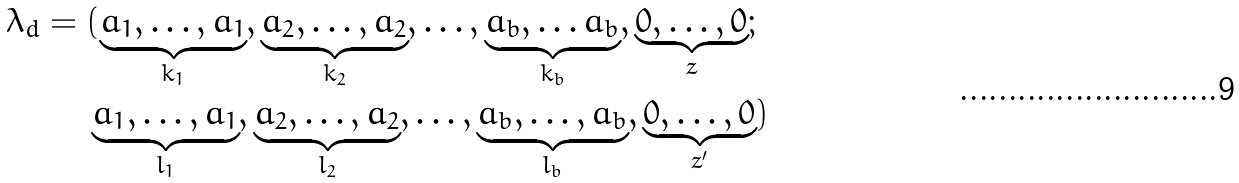<formula> <loc_0><loc_0><loc_500><loc_500>\lambda _ { d } & = ( \underbrace { a _ { 1 } , \dots , a _ { 1 } } _ { k _ { 1 } } , \underbrace { a _ { 2 } , \dots , a _ { 2 } } _ { k _ { 2 } } , \dots , \underbrace { a _ { b } , \dots a _ { b } } _ { k _ { b } } , \underbrace { 0 , \dots , 0 } _ { z } ; \\ & \quad \ \underbrace { a _ { 1 } , \dots , a _ { 1 } } _ { l _ { 1 } } , \underbrace { a _ { 2 } , \dots , a _ { 2 } } _ { l _ { 2 } } , \dots , \underbrace { a _ { b } , \dots , a _ { b } } _ { l _ { b } } , \underbrace { 0 , \dots , 0 } _ { z ^ { \prime } } )</formula> 